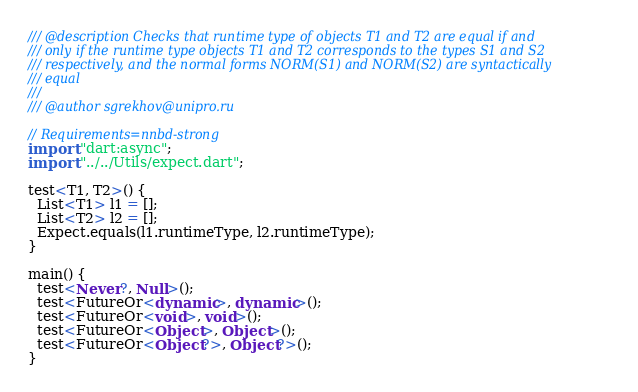Convert code to text. <code><loc_0><loc_0><loc_500><loc_500><_Dart_>/// @description Checks that runtime type of objects T1 and T2 are equal if and
/// only if the runtime type objects T1 and T2 corresponds to the types S1 and S2
/// respectively, and the normal forms NORM(S1) and NORM(S2) are syntactically
/// equal
///
/// @author sgrekhov@unipro.ru

// Requirements=nnbd-strong
import "dart:async";
import "../../Utils/expect.dart";

test<T1, T2>() {
  List<T1> l1 = [];
  List<T2> l2 = [];
  Expect.equals(l1.runtimeType, l2.runtimeType);
}

main() {
  test<Never?, Null>();
  test<FutureOr<dynamic>, dynamic>();
  test<FutureOr<void>, void>();
  test<FutureOr<Object>, Object>();
  test<FutureOr<Object?>, Object?>();
}
</code> 